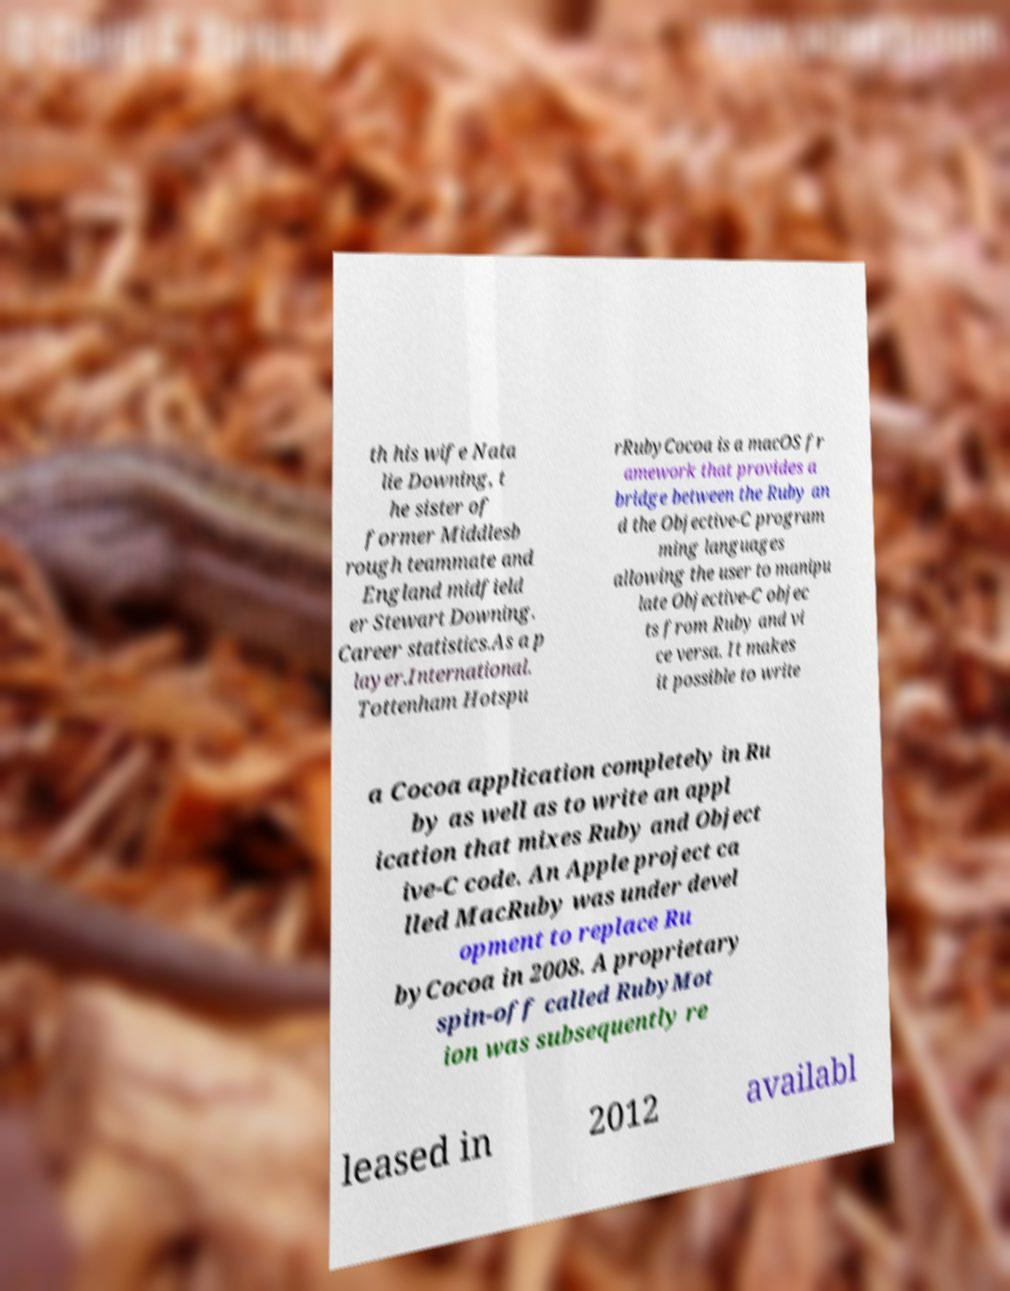Can you read and provide the text displayed in the image?This photo seems to have some interesting text. Can you extract and type it out for me? th his wife Nata lie Downing, t he sister of former Middlesb rough teammate and England midfield er Stewart Downing. Career statistics.As a p layer.International. Tottenham Hotspu rRubyCocoa is a macOS fr amework that provides a bridge between the Ruby an d the Objective-C program ming languages allowing the user to manipu late Objective-C objec ts from Ruby and vi ce versa. It makes it possible to write a Cocoa application completely in Ru by as well as to write an appl ication that mixes Ruby and Object ive-C code. An Apple project ca lled MacRuby was under devel opment to replace Ru byCocoa in 2008. A proprietary spin-off called RubyMot ion was subsequently re leased in 2012 availabl 